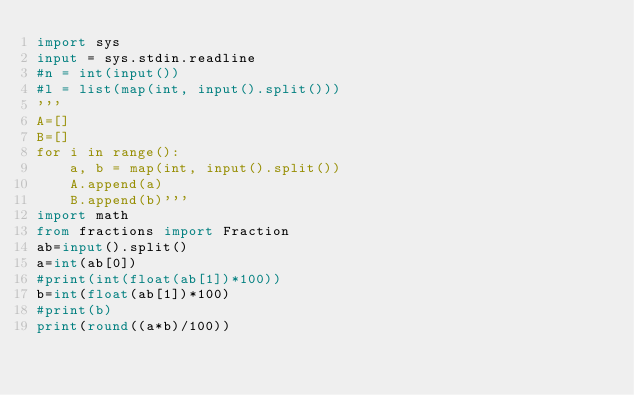Convert code to text. <code><loc_0><loc_0><loc_500><loc_500><_Python_>import sys
input = sys.stdin.readline
#n = int(input())
#l = list(map(int, input().split()))
'''
A=[]
B=[]
for i in range():
    a, b = map(int, input().split())
    A.append(a)
    B.append(b)'''
import math
from fractions import Fraction
ab=input().split()
a=int(ab[0])
#print(int(float(ab[1])*100))
b=int(float(ab[1])*100)
#print(b)
print(round((a*b)/100))

</code> 